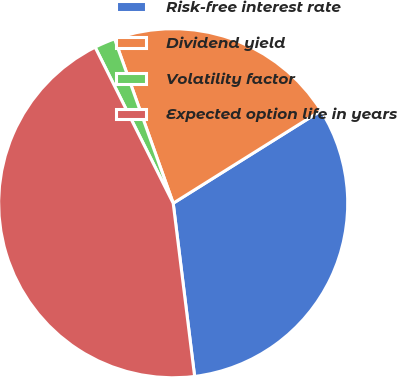<chart> <loc_0><loc_0><loc_500><loc_500><pie_chart><fcel>Risk-free interest rate<fcel>Dividend yield<fcel>Volatility factor<fcel>Expected option life in years<nl><fcel>31.95%<fcel>21.55%<fcel>1.93%<fcel>44.58%<nl></chart> 